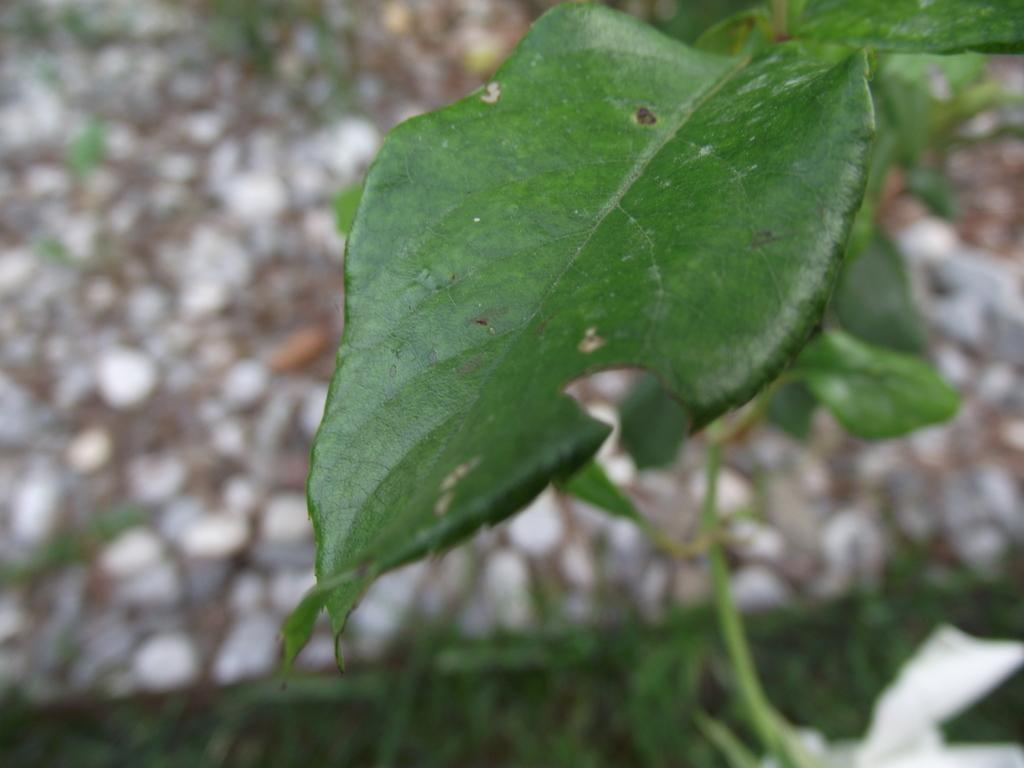What is the main subject in the front of the image? There is a green leaf in the front of the image. Can you describe the background of the image? There are more leaves visible in the background of the image. How would you describe the quality of the image in the background? The image is slightly blurry in the background. What type of tooth is visible in the image? There is no tooth present in the image; it features a green leaf in the front and more leaves in the background. 